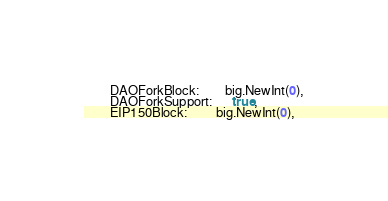Convert code to text. <code><loc_0><loc_0><loc_500><loc_500><_Go_>		DAOForkBlock:        big.NewInt(0),
		DAOForkSupport:      true,
		EIP150Block:         big.NewInt(0),</code> 